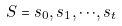<formula> <loc_0><loc_0><loc_500><loc_500>S = s _ { 0 } , s _ { 1 } , \cdot \cdot \cdot , s _ { t }</formula> 